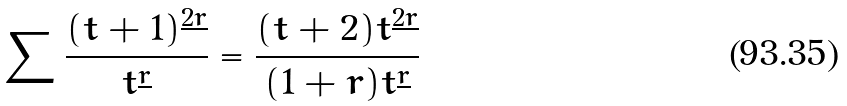<formula> <loc_0><loc_0><loc_500><loc_500>\sum \frac { ( t + 1 ) ^ { \underline { 2 r } } } { t ^ { \underline { r } } } = \frac { ( t + 2 ) t ^ { \underline { 2 r } } } { ( 1 + r ) t ^ { \underline { r } } }</formula> 